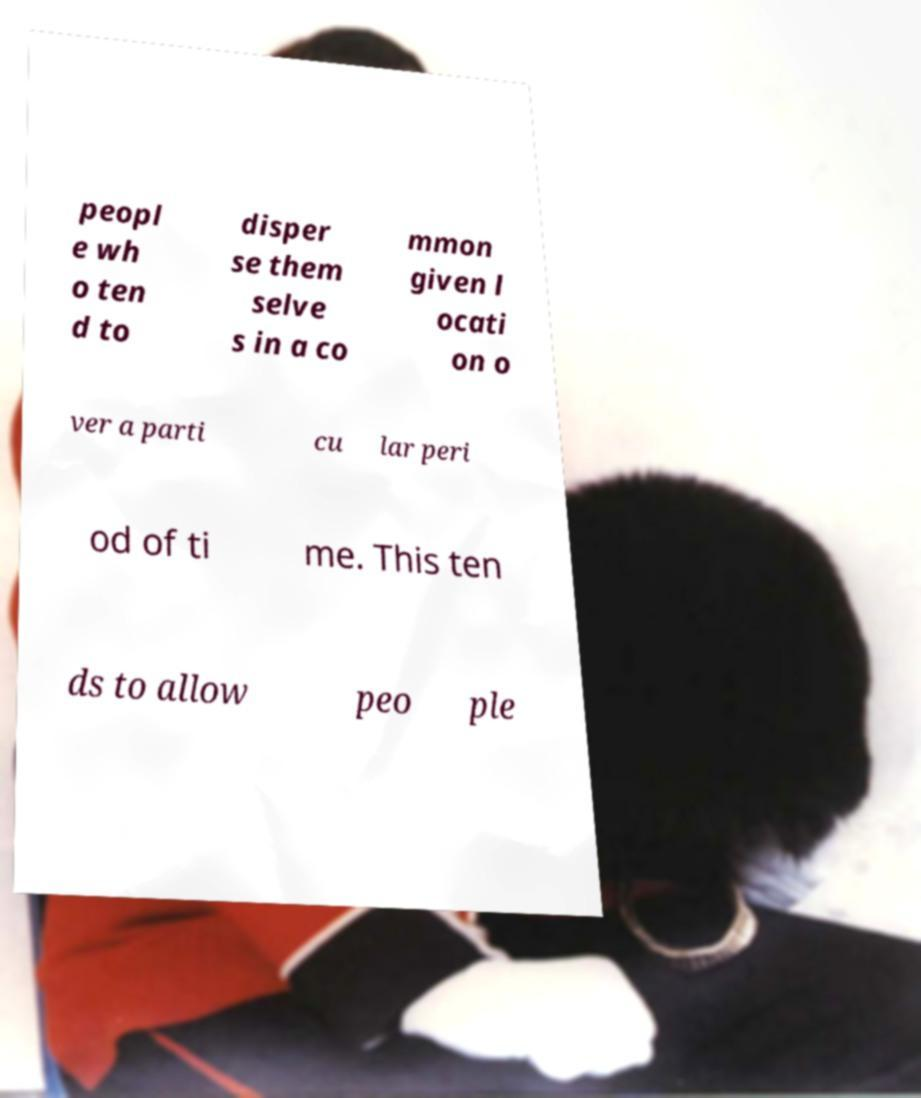Please read and relay the text visible in this image. What does it say? peopl e wh o ten d to disper se them selve s in a co mmon given l ocati on o ver a parti cu lar peri od of ti me. This ten ds to allow peo ple 